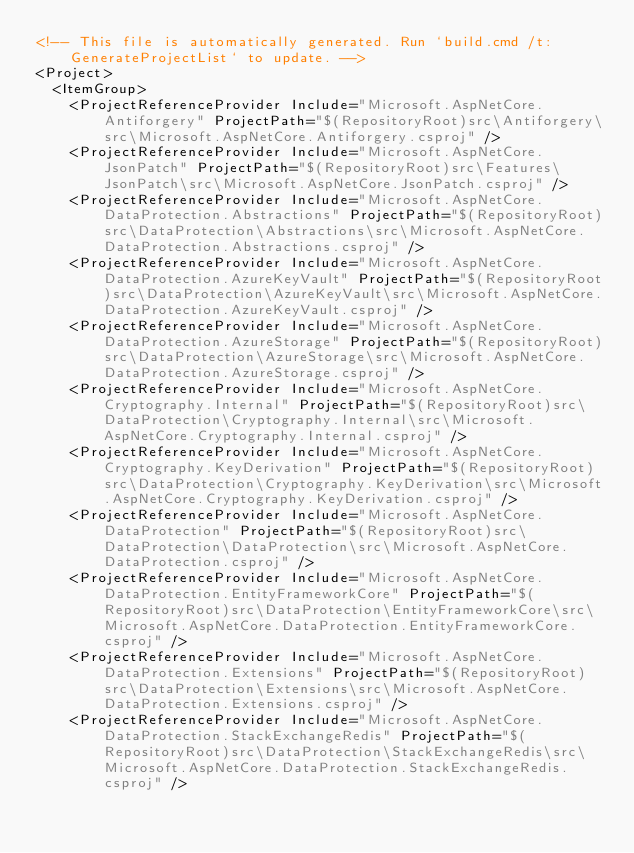Convert code to text. <code><loc_0><loc_0><loc_500><loc_500><_XML_><!-- This file is automatically generated. Run `build.cmd /t:GenerateProjectList` to update. -->
<Project>
  <ItemGroup>
    <ProjectReferenceProvider Include="Microsoft.AspNetCore.Antiforgery" ProjectPath="$(RepositoryRoot)src\Antiforgery\src\Microsoft.AspNetCore.Antiforgery.csproj" />
    <ProjectReferenceProvider Include="Microsoft.AspNetCore.JsonPatch" ProjectPath="$(RepositoryRoot)src\Features\JsonPatch\src\Microsoft.AspNetCore.JsonPatch.csproj" />
    <ProjectReferenceProvider Include="Microsoft.AspNetCore.DataProtection.Abstractions" ProjectPath="$(RepositoryRoot)src\DataProtection\Abstractions\src\Microsoft.AspNetCore.DataProtection.Abstractions.csproj" />
    <ProjectReferenceProvider Include="Microsoft.AspNetCore.DataProtection.AzureKeyVault" ProjectPath="$(RepositoryRoot)src\DataProtection\AzureKeyVault\src\Microsoft.AspNetCore.DataProtection.AzureKeyVault.csproj" />
    <ProjectReferenceProvider Include="Microsoft.AspNetCore.DataProtection.AzureStorage" ProjectPath="$(RepositoryRoot)src\DataProtection\AzureStorage\src\Microsoft.AspNetCore.DataProtection.AzureStorage.csproj" />
    <ProjectReferenceProvider Include="Microsoft.AspNetCore.Cryptography.Internal" ProjectPath="$(RepositoryRoot)src\DataProtection\Cryptography.Internal\src\Microsoft.AspNetCore.Cryptography.Internal.csproj" />
    <ProjectReferenceProvider Include="Microsoft.AspNetCore.Cryptography.KeyDerivation" ProjectPath="$(RepositoryRoot)src\DataProtection\Cryptography.KeyDerivation\src\Microsoft.AspNetCore.Cryptography.KeyDerivation.csproj" />
    <ProjectReferenceProvider Include="Microsoft.AspNetCore.DataProtection" ProjectPath="$(RepositoryRoot)src\DataProtection\DataProtection\src\Microsoft.AspNetCore.DataProtection.csproj" />
    <ProjectReferenceProvider Include="Microsoft.AspNetCore.DataProtection.EntityFrameworkCore" ProjectPath="$(RepositoryRoot)src\DataProtection\EntityFrameworkCore\src\Microsoft.AspNetCore.DataProtection.EntityFrameworkCore.csproj" />
    <ProjectReferenceProvider Include="Microsoft.AspNetCore.DataProtection.Extensions" ProjectPath="$(RepositoryRoot)src\DataProtection\Extensions\src\Microsoft.AspNetCore.DataProtection.Extensions.csproj" />
    <ProjectReferenceProvider Include="Microsoft.AspNetCore.DataProtection.StackExchangeRedis" ProjectPath="$(RepositoryRoot)src\DataProtection\StackExchangeRedis\src\Microsoft.AspNetCore.DataProtection.StackExchangeRedis.csproj" /></code> 